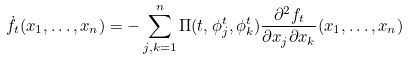Convert formula to latex. <formula><loc_0><loc_0><loc_500><loc_500>\dot { f } _ { t } ( x _ { 1 } , \dots , x _ { n } ) = - \sum _ { j , k = 1 } ^ { n } \Pi ( t , \phi _ { j } ^ { t } , \phi _ { k } ^ { t } ) \frac { \partial ^ { 2 } f _ { t } } { \partial x _ { j } \partial x _ { k } } ( x _ { 1 } , \dots , x _ { n } )</formula> 